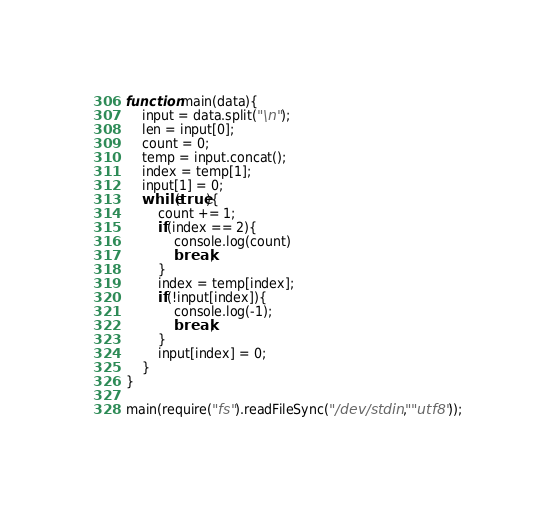Convert code to text. <code><loc_0><loc_0><loc_500><loc_500><_JavaScript_>function main(data){
    input = data.split("\n");
    len = input[0];
    count = 0;
    temp = input.concat();
    index = temp[1];
    input[1] = 0;
    while(true){
        count += 1;
        if(index == 2){
            console.log(count)
            break;
        }
        index = temp[index];
        if(!input[index]){
            console.log(-1);
            break;
        }
        input[index] = 0;
    }
}

main(require("fs").readFileSync("/dev/stdin", "utf8"));</code> 